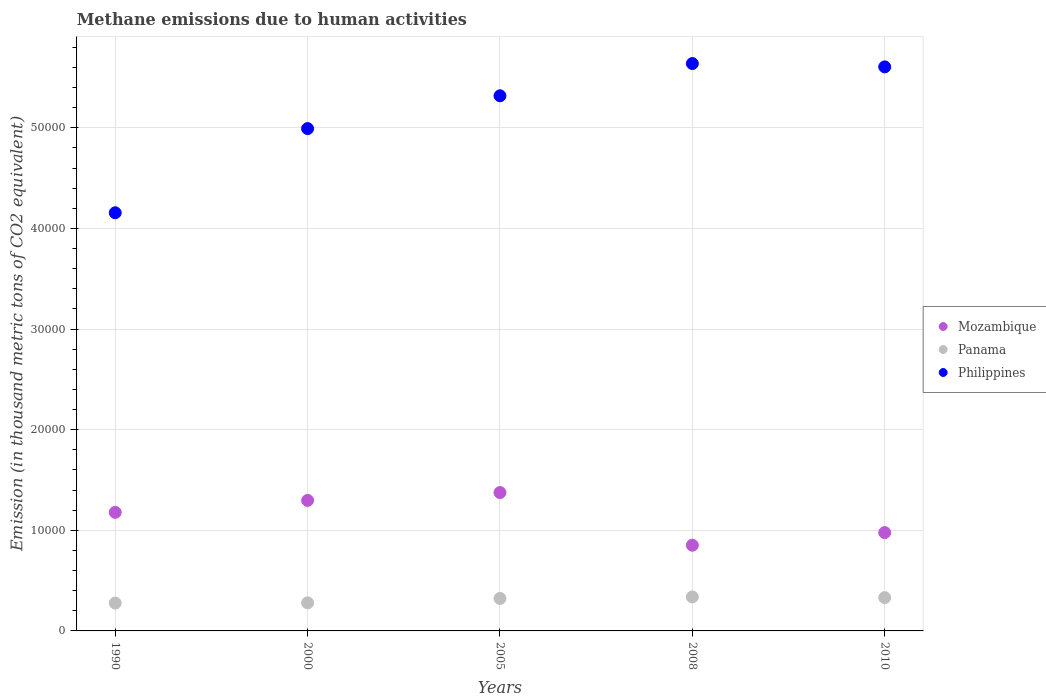What is the amount of methane emitted in Panama in 2005?
Your answer should be compact. 3225.9. Across all years, what is the maximum amount of methane emitted in Panama?
Ensure brevity in your answer.  3375.7. Across all years, what is the minimum amount of methane emitted in Philippines?
Your answer should be very brief. 4.16e+04. What is the total amount of methane emitted in Mozambique in the graph?
Keep it short and to the point. 5.68e+04. What is the difference between the amount of methane emitted in Mozambique in 1990 and that in 2000?
Ensure brevity in your answer.  -1187.6. What is the difference between the amount of methane emitted in Philippines in 2008 and the amount of methane emitted in Mozambique in 2010?
Make the answer very short. 4.66e+04. What is the average amount of methane emitted in Philippines per year?
Offer a terse response. 5.14e+04. In the year 2005, what is the difference between the amount of methane emitted in Panama and amount of methane emitted in Philippines?
Your answer should be compact. -4.99e+04. What is the ratio of the amount of methane emitted in Panama in 1990 to that in 2000?
Provide a succinct answer. 0.99. What is the difference between the highest and the second highest amount of methane emitted in Philippines?
Give a very brief answer. 330.4. What is the difference between the highest and the lowest amount of methane emitted in Mozambique?
Your response must be concise. 5232.1. In how many years, is the amount of methane emitted in Panama greater than the average amount of methane emitted in Panama taken over all years?
Your answer should be compact. 3. Does the amount of methane emitted in Panama monotonically increase over the years?
Your answer should be very brief. No. Is the amount of methane emitted in Philippines strictly greater than the amount of methane emitted in Panama over the years?
Your answer should be compact. Yes. Is the amount of methane emitted in Panama strictly less than the amount of methane emitted in Mozambique over the years?
Ensure brevity in your answer.  Yes. What is the difference between two consecutive major ticks on the Y-axis?
Ensure brevity in your answer.  10000. Does the graph contain any zero values?
Provide a short and direct response. No. What is the title of the graph?
Provide a short and direct response. Methane emissions due to human activities. Does "Kenya" appear as one of the legend labels in the graph?
Provide a short and direct response. No. What is the label or title of the Y-axis?
Offer a very short reply. Emission (in thousand metric tons of CO2 equivalent). What is the Emission (in thousand metric tons of CO2 equivalent) in Mozambique in 1990?
Give a very brief answer. 1.18e+04. What is the Emission (in thousand metric tons of CO2 equivalent) of Panama in 1990?
Your response must be concise. 2769.4. What is the Emission (in thousand metric tons of CO2 equivalent) of Philippines in 1990?
Offer a terse response. 4.16e+04. What is the Emission (in thousand metric tons of CO2 equivalent) of Mozambique in 2000?
Your response must be concise. 1.30e+04. What is the Emission (in thousand metric tons of CO2 equivalent) in Panama in 2000?
Offer a very short reply. 2789.9. What is the Emission (in thousand metric tons of CO2 equivalent) of Philippines in 2000?
Ensure brevity in your answer.  4.99e+04. What is the Emission (in thousand metric tons of CO2 equivalent) in Mozambique in 2005?
Offer a terse response. 1.37e+04. What is the Emission (in thousand metric tons of CO2 equivalent) of Panama in 2005?
Provide a short and direct response. 3225.9. What is the Emission (in thousand metric tons of CO2 equivalent) in Philippines in 2005?
Your answer should be very brief. 5.32e+04. What is the Emission (in thousand metric tons of CO2 equivalent) of Mozambique in 2008?
Your answer should be very brief. 8517.4. What is the Emission (in thousand metric tons of CO2 equivalent) of Panama in 2008?
Your response must be concise. 3375.7. What is the Emission (in thousand metric tons of CO2 equivalent) in Philippines in 2008?
Offer a very short reply. 5.64e+04. What is the Emission (in thousand metric tons of CO2 equivalent) of Mozambique in 2010?
Offer a very short reply. 9772.4. What is the Emission (in thousand metric tons of CO2 equivalent) of Panama in 2010?
Offer a terse response. 3311.6. What is the Emission (in thousand metric tons of CO2 equivalent) in Philippines in 2010?
Your response must be concise. 5.60e+04. Across all years, what is the maximum Emission (in thousand metric tons of CO2 equivalent) in Mozambique?
Provide a succinct answer. 1.37e+04. Across all years, what is the maximum Emission (in thousand metric tons of CO2 equivalent) of Panama?
Keep it short and to the point. 3375.7. Across all years, what is the maximum Emission (in thousand metric tons of CO2 equivalent) in Philippines?
Provide a succinct answer. 5.64e+04. Across all years, what is the minimum Emission (in thousand metric tons of CO2 equivalent) in Mozambique?
Your answer should be compact. 8517.4. Across all years, what is the minimum Emission (in thousand metric tons of CO2 equivalent) in Panama?
Your response must be concise. 2769.4. Across all years, what is the minimum Emission (in thousand metric tons of CO2 equivalent) of Philippines?
Provide a succinct answer. 4.16e+04. What is the total Emission (in thousand metric tons of CO2 equivalent) of Mozambique in the graph?
Give a very brief answer. 5.68e+04. What is the total Emission (in thousand metric tons of CO2 equivalent) of Panama in the graph?
Ensure brevity in your answer.  1.55e+04. What is the total Emission (in thousand metric tons of CO2 equivalent) of Philippines in the graph?
Your response must be concise. 2.57e+05. What is the difference between the Emission (in thousand metric tons of CO2 equivalent) of Mozambique in 1990 and that in 2000?
Provide a short and direct response. -1187.6. What is the difference between the Emission (in thousand metric tons of CO2 equivalent) of Panama in 1990 and that in 2000?
Your answer should be compact. -20.5. What is the difference between the Emission (in thousand metric tons of CO2 equivalent) in Philippines in 1990 and that in 2000?
Provide a short and direct response. -8363.6. What is the difference between the Emission (in thousand metric tons of CO2 equivalent) of Mozambique in 1990 and that in 2005?
Your answer should be very brief. -1966.8. What is the difference between the Emission (in thousand metric tons of CO2 equivalent) of Panama in 1990 and that in 2005?
Make the answer very short. -456.5. What is the difference between the Emission (in thousand metric tons of CO2 equivalent) in Philippines in 1990 and that in 2005?
Your answer should be compact. -1.16e+04. What is the difference between the Emission (in thousand metric tons of CO2 equivalent) of Mozambique in 1990 and that in 2008?
Keep it short and to the point. 3265.3. What is the difference between the Emission (in thousand metric tons of CO2 equivalent) in Panama in 1990 and that in 2008?
Ensure brevity in your answer.  -606.3. What is the difference between the Emission (in thousand metric tons of CO2 equivalent) in Philippines in 1990 and that in 2008?
Give a very brief answer. -1.48e+04. What is the difference between the Emission (in thousand metric tons of CO2 equivalent) of Mozambique in 1990 and that in 2010?
Provide a short and direct response. 2010.3. What is the difference between the Emission (in thousand metric tons of CO2 equivalent) of Panama in 1990 and that in 2010?
Offer a terse response. -542.2. What is the difference between the Emission (in thousand metric tons of CO2 equivalent) of Philippines in 1990 and that in 2010?
Give a very brief answer. -1.45e+04. What is the difference between the Emission (in thousand metric tons of CO2 equivalent) in Mozambique in 2000 and that in 2005?
Give a very brief answer. -779.2. What is the difference between the Emission (in thousand metric tons of CO2 equivalent) in Panama in 2000 and that in 2005?
Offer a terse response. -436. What is the difference between the Emission (in thousand metric tons of CO2 equivalent) of Philippines in 2000 and that in 2005?
Offer a terse response. -3260.6. What is the difference between the Emission (in thousand metric tons of CO2 equivalent) in Mozambique in 2000 and that in 2008?
Provide a succinct answer. 4452.9. What is the difference between the Emission (in thousand metric tons of CO2 equivalent) in Panama in 2000 and that in 2008?
Offer a very short reply. -585.8. What is the difference between the Emission (in thousand metric tons of CO2 equivalent) in Philippines in 2000 and that in 2008?
Make the answer very short. -6464.7. What is the difference between the Emission (in thousand metric tons of CO2 equivalent) of Mozambique in 2000 and that in 2010?
Keep it short and to the point. 3197.9. What is the difference between the Emission (in thousand metric tons of CO2 equivalent) in Panama in 2000 and that in 2010?
Offer a very short reply. -521.7. What is the difference between the Emission (in thousand metric tons of CO2 equivalent) of Philippines in 2000 and that in 2010?
Your response must be concise. -6134.3. What is the difference between the Emission (in thousand metric tons of CO2 equivalent) in Mozambique in 2005 and that in 2008?
Provide a succinct answer. 5232.1. What is the difference between the Emission (in thousand metric tons of CO2 equivalent) in Panama in 2005 and that in 2008?
Your answer should be compact. -149.8. What is the difference between the Emission (in thousand metric tons of CO2 equivalent) in Philippines in 2005 and that in 2008?
Provide a short and direct response. -3204.1. What is the difference between the Emission (in thousand metric tons of CO2 equivalent) in Mozambique in 2005 and that in 2010?
Give a very brief answer. 3977.1. What is the difference between the Emission (in thousand metric tons of CO2 equivalent) in Panama in 2005 and that in 2010?
Keep it short and to the point. -85.7. What is the difference between the Emission (in thousand metric tons of CO2 equivalent) of Philippines in 2005 and that in 2010?
Ensure brevity in your answer.  -2873.7. What is the difference between the Emission (in thousand metric tons of CO2 equivalent) in Mozambique in 2008 and that in 2010?
Your answer should be compact. -1255. What is the difference between the Emission (in thousand metric tons of CO2 equivalent) in Panama in 2008 and that in 2010?
Your answer should be very brief. 64.1. What is the difference between the Emission (in thousand metric tons of CO2 equivalent) in Philippines in 2008 and that in 2010?
Provide a short and direct response. 330.4. What is the difference between the Emission (in thousand metric tons of CO2 equivalent) of Mozambique in 1990 and the Emission (in thousand metric tons of CO2 equivalent) of Panama in 2000?
Provide a succinct answer. 8992.8. What is the difference between the Emission (in thousand metric tons of CO2 equivalent) in Mozambique in 1990 and the Emission (in thousand metric tons of CO2 equivalent) in Philippines in 2000?
Ensure brevity in your answer.  -3.81e+04. What is the difference between the Emission (in thousand metric tons of CO2 equivalent) in Panama in 1990 and the Emission (in thousand metric tons of CO2 equivalent) in Philippines in 2000?
Your answer should be very brief. -4.71e+04. What is the difference between the Emission (in thousand metric tons of CO2 equivalent) in Mozambique in 1990 and the Emission (in thousand metric tons of CO2 equivalent) in Panama in 2005?
Your answer should be compact. 8556.8. What is the difference between the Emission (in thousand metric tons of CO2 equivalent) of Mozambique in 1990 and the Emission (in thousand metric tons of CO2 equivalent) of Philippines in 2005?
Provide a succinct answer. -4.14e+04. What is the difference between the Emission (in thousand metric tons of CO2 equivalent) in Panama in 1990 and the Emission (in thousand metric tons of CO2 equivalent) in Philippines in 2005?
Ensure brevity in your answer.  -5.04e+04. What is the difference between the Emission (in thousand metric tons of CO2 equivalent) in Mozambique in 1990 and the Emission (in thousand metric tons of CO2 equivalent) in Panama in 2008?
Your answer should be compact. 8407. What is the difference between the Emission (in thousand metric tons of CO2 equivalent) in Mozambique in 1990 and the Emission (in thousand metric tons of CO2 equivalent) in Philippines in 2008?
Offer a terse response. -4.46e+04. What is the difference between the Emission (in thousand metric tons of CO2 equivalent) of Panama in 1990 and the Emission (in thousand metric tons of CO2 equivalent) of Philippines in 2008?
Offer a very short reply. -5.36e+04. What is the difference between the Emission (in thousand metric tons of CO2 equivalent) of Mozambique in 1990 and the Emission (in thousand metric tons of CO2 equivalent) of Panama in 2010?
Give a very brief answer. 8471.1. What is the difference between the Emission (in thousand metric tons of CO2 equivalent) in Mozambique in 1990 and the Emission (in thousand metric tons of CO2 equivalent) in Philippines in 2010?
Your answer should be compact. -4.43e+04. What is the difference between the Emission (in thousand metric tons of CO2 equivalent) of Panama in 1990 and the Emission (in thousand metric tons of CO2 equivalent) of Philippines in 2010?
Offer a very short reply. -5.33e+04. What is the difference between the Emission (in thousand metric tons of CO2 equivalent) of Mozambique in 2000 and the Emission (in thousand metric tons of CO2 equivalent) of Panama in 2005?
Your response must be concise. 9744.4. What is the difference between the Emission (in thousand metric tons of CO2 equivalent) of Mozambique in 2000 and the Emission (in thousand metric tons of CO2 equivalent) of Philippines in 2005?
Make the answer very short. -4.02e+04. What is the difference between the Emission (in thousand metric tons of CO2 equivalent) in Panama in 2000 and the Emission (in thousand metric tons of CO2 equivalent) in Philippines in 2005?
Provide a short and direct response. -5.04e+04. What is the difference between the Emission (in thousand metric tons of CO2 equivalent) of Mozambique in 2000 and the Emission (in thousand metric tons of CO2 equivalent) of Panama in 2008?
Make the answer very short. 9594.6. What is the difference between the Emission (in thousand metric tons of CO2 equivalent) in Mozambique in 2000 and the Emission (in thousand metric tons of CO2 equivalent) in Philippines in 2008?
Your response must be concise. -4.34e+04. What is the difference between the Emission (in thousand metric tons of CO2 equivalent) in Panama in 2000 and the Emission (in thousand metric tons of CO2 equivalent) in Philippines in 2008?
Offer a very short reply. -5.36e+04. What is the difference between the Emission (in thousand metric tons of CO2 equivalent) in Mozambique in 2000 and the Emission (in thousand metric tons of CO2 equivalent) in Panama in 2010?
Provide a short and direct response. 9658.7. What is the difference between the Emission (in thousand metric tons of CO2 equivalent) of Mozambique in 2000 and the Emission (in thousand metric tons of CO2 equivalent) of Philippines in 2010?
Give a very brief answer. -4.31e+04. What is the difference between the Emission (in thousand metric tons of CO2 equivalent) in Panama in 2000 and the Emission (in thousand metric tons of CO2 equivalent) in Philippines in 2010?
Your response must be concise. -5.33e+04. What is the difference between the Emission (in thousand metric tons of CO2 equivalent) in Mozambique in 2005 and the Emission (in thousand metric tons of CO2 equivalent) in Panama in 2008?
Make the answer very short. 1.04e+04. What is the difference between the Emission (in thousand metric tons of CO2 equivalent) of Mozambique in 2005 and the Emission (in thousand metric tons of CO2 equivalent) of Philippines in 2008?
Provide a short and direct response. -4.26e+04. What is the difference between the Emission (in thousand metric tons of CO2 equivalent) in Panama in 2005 and the Emission (in thousand metric tons of CO2 equivalent) in Philippines in 2008?
Offer a very short reply. -5.32e+04. What is the difference between the Emission (in thousand metric tons of CO2 equivalent) of Mozambique in 2005 and the Emission (in thousand metric tons of CO2 equivalent) of Panama in 2010?
Offer a very short reply. 1.04e+04. What is the difference between the Emission (in thousand metric tons of CO2 equivalent) of Mozambique in 2005 and the Emission (in thousand metric tons of CO2 equivalent) of Philippines in 2010?
Offer a terse response. -4.23e+04. What is the difference between the Emission (in thousand metric tons of CO2 equivalent) of Panama in 2005 and the Emission (in thousand metric tons of CO2 equivalent) of Philippines in 2010?
Your answer should be compact. -5.28e+04. What is the difference between the Emission (in thousand metric tons of CO2 equivalent) in Mozambique in 2008 and the Emission (in thousand metric tons of CO2 equivalent) in Panama in 2010?
Keep it short and to the point. 5205.8. What is the difference between the Emission (in thousand metric tons of CO2 equivalent) in Mozambique in 2008 and the Emission (in thousand metric tons of CO2 equivalent) in Philippines in 2010?
Offer a terse response. -4.75e+04. What is the difference between the Emission (in thousand metric tons of CO2 equivalent) of Panama in 2008 and the Emission (in thousand metric tons of CO2 equivalent) of Philippines in 2010?
Offer a very short reply. -5.27e+04. What is the average Emission (in thousand metric tons of CO2 equivalent) in Mozambique per year?
Provide a short and direct response. 1.14e+04. What is the average Emission (in thousand metric tons of CO2 equivalent) of Panama per year?
Provide a succinct answer. 3094.5. What is the average Emission (in thousand metric tons of CO2 equivalent) in Philippines per year?
Give a very brief answer. 5.14e+04. In the year 1990, what is the difference between the Emission (in thousand metric tons of CO2 equivalent) in Mozambique and Emission (in thousand metric tons of CO2 equivalent) in Panama?
Offer a very short reply. 9013.3. In the year 1990, what is the difference between the Emission (in thousand metric tons of CO2 equivalent) in Mozambique and Emission (in thousand metric tons of CO2 equivalent) in Philippines?
Ensure brevity in your answer.  -2.98e+04. In the year 1990, what is the difference between the Emission (in thousand metric tons of CO2 equivalent) of Panama and Emission (in thousand metric tons of CO2 equivalent) of Philippines?
Keep it short and to the point. -3.88e+04. In the year 2000, what is the difference between the Emission (in thousand metric tons of CO2 equivalent) of Mozambique and Emission (in thousand metric tons of CO2 equivalent) of Panama?
Your answer should be compact. 1.02e+04. In the year 2000, what is the difference between the Emission (in thousand metric tons of CO2 equivalent) in Mozambique and Emission (in thousand metric tons of CO2 equivalent) in Philippines?
Keep it short and to the point. -3.69e+04. In the year 2000, what is the difference between the Emission (in thousand metric tons of CO2 equivalent) in Panama and Emission (in thousand metric tons of CO2 equivalent) in Philippines?
Make the answer very short. -4.71e+04. In the year 2005, what is the difference between the Emission (in thousand metric tons of CO2 equivalent) of Mozambique and Emission (in thousand metric tons of CO2 equivalent) of Panama?
Offer a terse response. 1.05e+04. In the year 2005, what is the difference between the Emission (in thousand metric tons of CO2 equivalent) in Mozambique and Emission (in thousand metric tons of CO2 equivalent) in Philippines?
Keep it short and to the point. -3.94e+04. In the year 2005, what is the difference between the Emission (in thousand metric tons of CO2 equivalent) of Panama and Emission (in thousand metric tons of CO2 equivalent) of Philippines?
Give a very brief answer. -4.99e+04. In the year 2008, what is the difference between the Emission (in thousand metric tons of CO2 equivalent) in Mozambique and Emission (in thousand metric tons of CO2 equivalent) in Panama?
Offer a very short reply. 5141.7. In the year 2008, what is the difference between the Emission (in thousand metric tons of CO2 equivalent) in Mozambique and Emission (in thousand metric tons of CO2 equivalent) in Philippines?
Make the answer very short. -4.79e+04. In the year 2008, what is the difference between the Emission (in thousand metric tons of CO2 equivalent) in Panama and Emission (in thousand metric tons of CO2 equivalent) in Philippines?
Ensure brevity in your answer.  -5.30e+04. In the year 2010, what is the difference between the Emission (in thousand metric tons of CO2 equivalent) in Mozambique and Emission (in thousand metric tons of CO2 equivalent) in Panama?
Offer a very short reply. 6460.8. In the year 2010, what is the difference between the Emission (in thousand metric tons of CO2 equivalent) of Mozambique and Emission (in thousand metric tons of CO2 equivalent) of Philippines?
Ensure brevity in your answer.  -4.63e+04. In the year 2010, what is the difference between the Emission (in thousand metric tons of CO2 equivalent) of Panama and Emission (in thousand metric tons of CO2 equivalent) of Philippines?
Give a very brief answer. -5.27e+04. What is the ratio of the Emission (in thousand metric tons of CO2 equivalent) of Mozambique in 1990 to that in 2000?
Your answer should be compact. 0.91. What is the ratio of the Emission (in thousand metric tons of CO2 equivalent) of Philippines in 1990 to that in 2000?
Your answer should be very brief. 0.83. What is the ratio of the Emission (in thousand metric tons of CO2 equivalent) of Mozambique in 1990 to that in 2005?
Provide a succinct answer. 0.86. What is the ratio of the Emission (in thousand metric tons of CO2 equivalent) in Panama in 1990 to that in 2005?
Ensure brevity in your answer.  0.86. What is the ratio of the Emission (in thousand metric tons of CO2 equivalent) of Philippines in 1990 to that in 2005?
Make the answer very short. 0.78. What is the ratio of the Emission (in thousand metric tons of CO2 equivalent) of Mozambique in 1990 to that in 2008?
Keep it short and to the point. 1.38. What is the ratio of the Emission (in thousand metric tons of CO2 equivalent) in Panama in 1990 to that in 2008?
Your answer should be compact. 0.82. What is the ratio of the Emission (in thousand metric tons of CO2 equivalent) in Philippines in 1990 to that in 2008?
Ensure brevity in your answer.  0.74. What is the ratio of the Emission (in thousand metric tons of CO2 equivalent) in Mozambique in 1990 to that in 2010?
Ensure brevity in your answer.  1.21. What is the ratio of the Emission (in thousand metric tons of CO2 equivalent) of Panama in 1990 to that in 2010?
Offer a very short reply. 0.84. What is the ratio of the Emission (in thousand metric tons of CO2 equivalent) of Philippines in 1990 to that in 2010?
Make the answer very short. 0.74. What is the ratio of the Emission (in thousand metric tons of CO2 equivalent) of Mozambique in 2000 to that in 2005?
Give a very brief answer. 0.94. What is the ratio of the Emission (in thousand metric tons of CO2 equivalent) of Panama in 2000 to that in 2005?
Offer a terse response. 0.86. What is the ratio of the Emission (in thousand metric tons of CO2 equivalent) of Philippines in 2000 to that in 2005?
Give a very brief answer. 0.94. What is the ratio of the Emission (in thousand metric tons of CO2 equivalent) of Mozambique in 2000 to that in 2008?
Make the answer very short. 1.52. What is the ratio of the Emission (in thousand metric tons of CO2 equivalent) in Panama in 2000 to that in 2008?
Your answer should be compact. 0.83. What is the ratio of the Emission (in thousand metric tons of CO2 equivalent) of Philippines in 2000 to that in 2008?
Keep it short and to the point. 0.89. What is the ratio of the Emission (in thousand metric tons of CO2 equivalent) in Mozambique in 2000 to that in 2010?
Provide a succinct answer. 1.33. What is the ratio of the Emission (in thousand metric tons of CO2 equivalent) of Panama in 2000 to that in 2010?
Offer a very short reply. 0.84. What is the ratio of the Emission (in thousand metric tons of CO2 equivalent) of Philippines in 2000 to that in 2010?
Make the answer very short. 0.89. What is the ratio of the Emission (in thousand metric tons of CO2 equivalent) of Mozambique in 2005 to that in 2008?
Ensure brevity in your answer.  1.61. What is the ratio of the Emission (in thousand metric tons of CO2 equivalent) of Panama in 2005 to that in 2008?
Ensure brevity in your answer.  0.96. What is the ratio of the Emission (in thousand metric tons of CO2 equivalent) of Philippines in 2005 to that in 2008?
Make the answer very short. 0.94. What is the ratio of the Emission (in thousand metric tons of CO2 equivalent) in Mozambique in 2005 to that in 2010?
Provide a short and direct response. 1.41. What is the ratio of the Emission (in thousand metric tons of CO2 equivalent) in Panama in 2005 to that in 2010?
Offer a very short reply. 0.97. What is the ratio of the Emission (in thousand metric tons of CO2 equivalent) of Philippines in 2005 to that in 2010?
Provide a succinct answer. 0.95. What is the ratio of the Emission (in thousand metric tons of CO2 equivalent) in Mozambique in 2008 to that in 2010?
Provide a succinct answer. 0.87. What is the ratio of the Emission (in thousand metric tons of CO2 equivalent) in Panama in 2008 to that in 2010?
Offer a terse response. 1.02. What is the ratio of the Emission (in thousand metric tons of CO2 equivalent) of Philippines in 2008 to that in 2010?
Give a very brief answer. 1.01. What is the difference between the highest and the second highest Emission (in thousand metric tons of CO2 equivalent) of Mozambique?
Your answer should be very brief. 779.2. What is the difference between the highest and the second highest Emission (in thousand metric tons of CO2 equivalent) of Panama?
Keep it short and to the point. 64.1. What is the difference between the highest and the second highest Emission (in thousand metric tons of CO2 equivalent) of Philippines?
Your answer should be very brief. 330.4. What is the difference between the highest and the lowest Emission (in thousand metric tons of CO2 equivalent) in Mozambique?
Make the answer very short. 5232.1. What is the difference between the highest and the lowest Emission (in thousand metric tons of CO2 equivalent) of Panama?
Ensure brevity in your answer.  606.3. What is the difference between the highest and the lowest Emission (in thousand metric tons of CO2 equivalent) in Philippines?
Provide a succinct answer. 1.48e+04. 